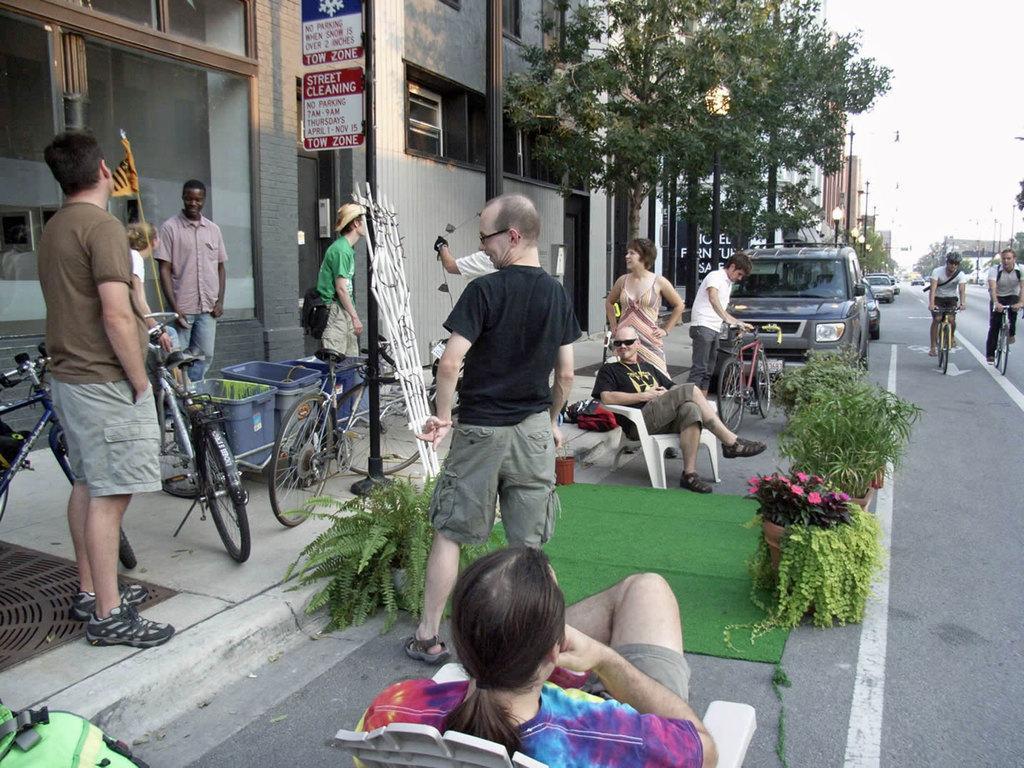Could you give a brief overview of what you see in this image? In this image, we can see few peoples are standing, 2 peoples are sat on the chairs. On the right side, 2 peoples are riding bicycles, we can see few vehicles. On left side, we can see baskets, bicycles, bags , some plants, mat and board, building, trees ,poles. Right side, we can see lights. 